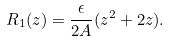<formula> <loc_0><loc_0><loc_500><loc_500>R _ { 1 } ( z ) = \frac { \epsilon } { 2 A } ( z ^ { 2 } + 2 z ) .</formula> 